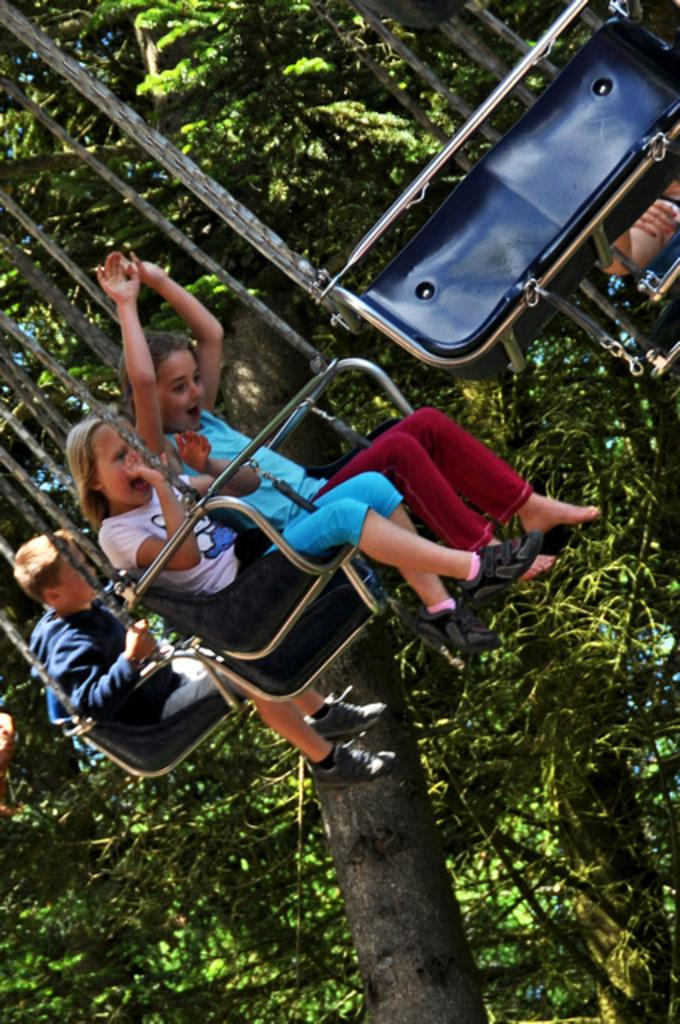How many kids are present in the image? There are three kids in the image. What are the kids doing in the image? The kids are taking an amusement ride. What can be seen in the background of the image? There are trees in the background of the image. What type of haircut does the stranger give to the kids in the image? There is no stranger present in the image, and therefore no haircuts are being given. 